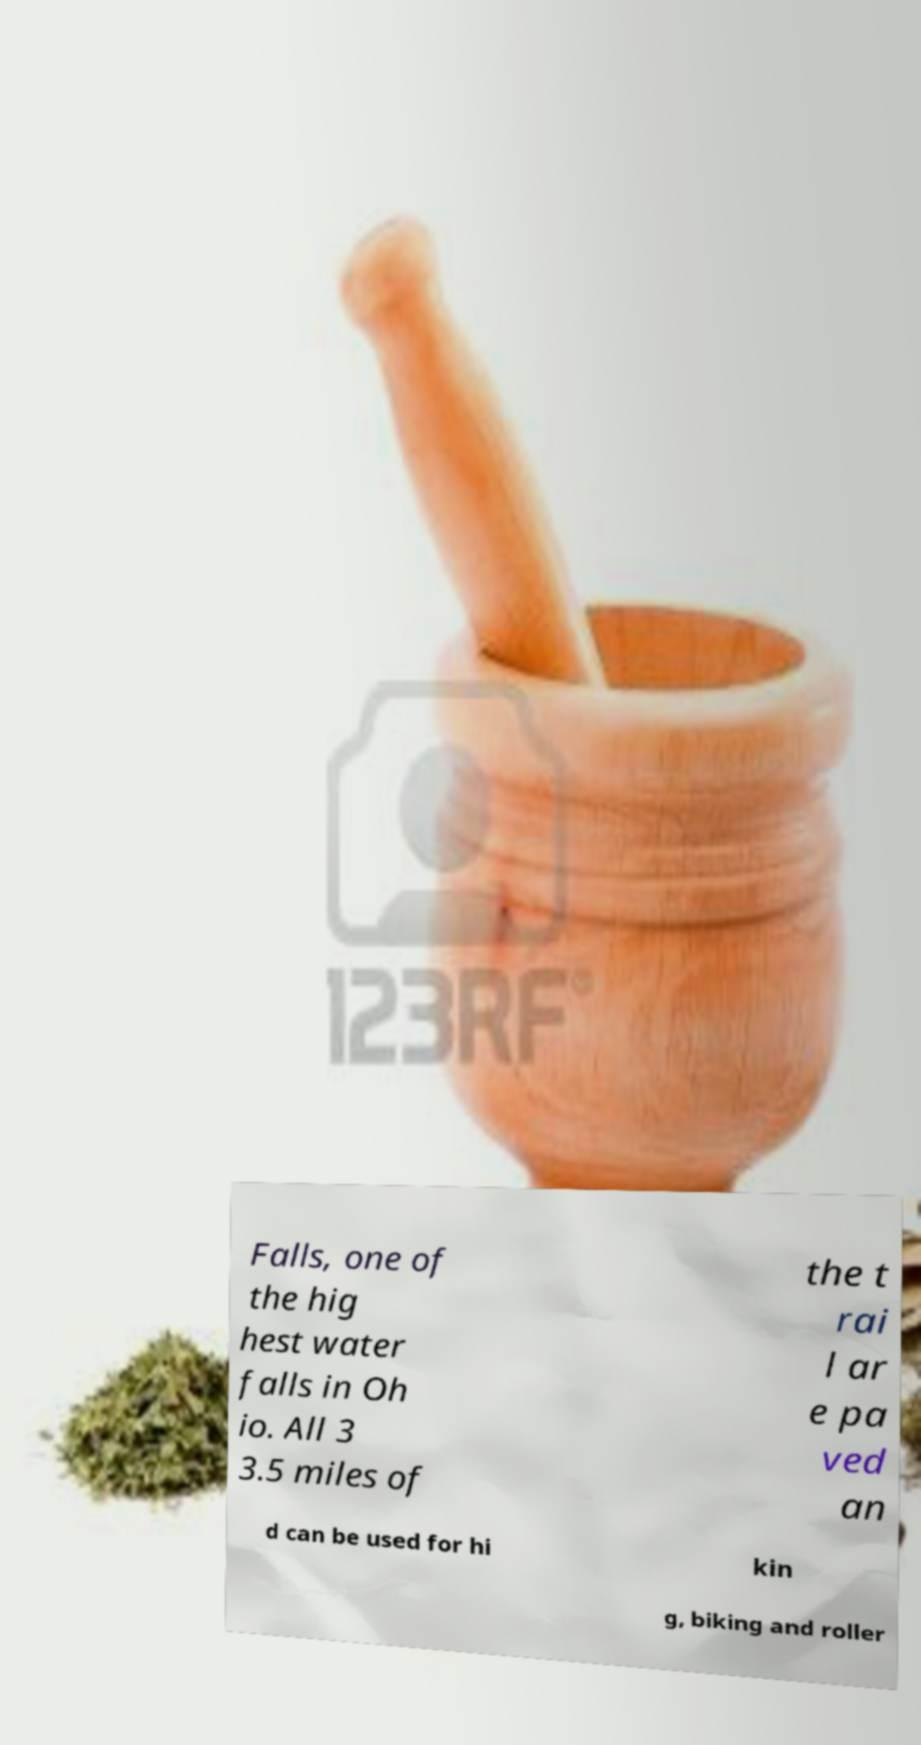I need the written content from this picture converted into text. Can you do that? Falls, one of the hig hest water falls in Oh io. All 3 3.5 miles of the t rai l ar e pa ved an d can be used for hi kin g, biking and roller 